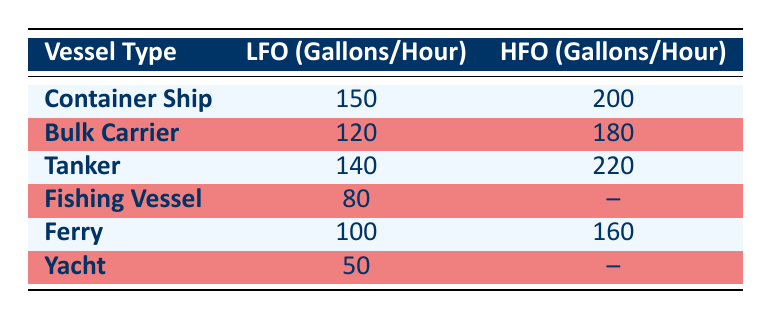What is the fuel consumption rate for Container Ships using LFO? The table lists the LFO fuel consumption rate for Container Ships as 150 gallons per hour.
Answer: 150 Which vessel type has the highest fuel consumption rate for HFO? By comparing the HFO consumption rates for all vessel types, the Tanker has the highest rate at 220 gallons per hour.
Answer: Tanker Is the fuel consumption for Fishing Vessels using HFO recorded in the table? The table indicates that the HFO consumption rate for Fishing Vessels is not provided and is marked as "--".
Answer: No What is the difference in fuel consumption rates between Bulk Carriers using LFO and HFO? The LFO consumption rate for Bulk Carriers is 120 gallons per hour and the HFO rate is 180 gallons per hour. The difference is calculated as 180 - 120 = 60 gallons per hour.
Answer: 60 Calculate the average LFO fuel consumption rate for all vessel types listed in the table. The LFO rates are 150, 120, 140, 80, 100, and 50 gallons per hour. The total is 150 + 120 + 140 + 80 + 100 + 50 = 640 gallons. There are 6 vessel types, so the average is 640 / 6 = approximately 106.67 gallons per hour.
Answer: 106.67 Are all vessel types listed in the table consuming fuel at a rate of more than 50 gallons per hour for LFO? The table shows that the Yacht consumes 50 gallons per hour for LFO, so not all listed vessel types exceed that consumption rate.
Answer: No Which vessel type has the lowest LFO fuel consumption rate? By reviewing the LFO consumption rates, the Yacht shows the lowest rate at 50 gallons per hour.
Answer: Yacht How does the fuel consumption for Ferries compare to that of Tankers in terms of HFO? Ferries consume 160 gallons per hour for HFO while Tankers consume 220 gallons per hour. Thus, Tankers consume 60 gallons more than Ferries for HFO.
Answer: Tankers consume 60 gallons more 